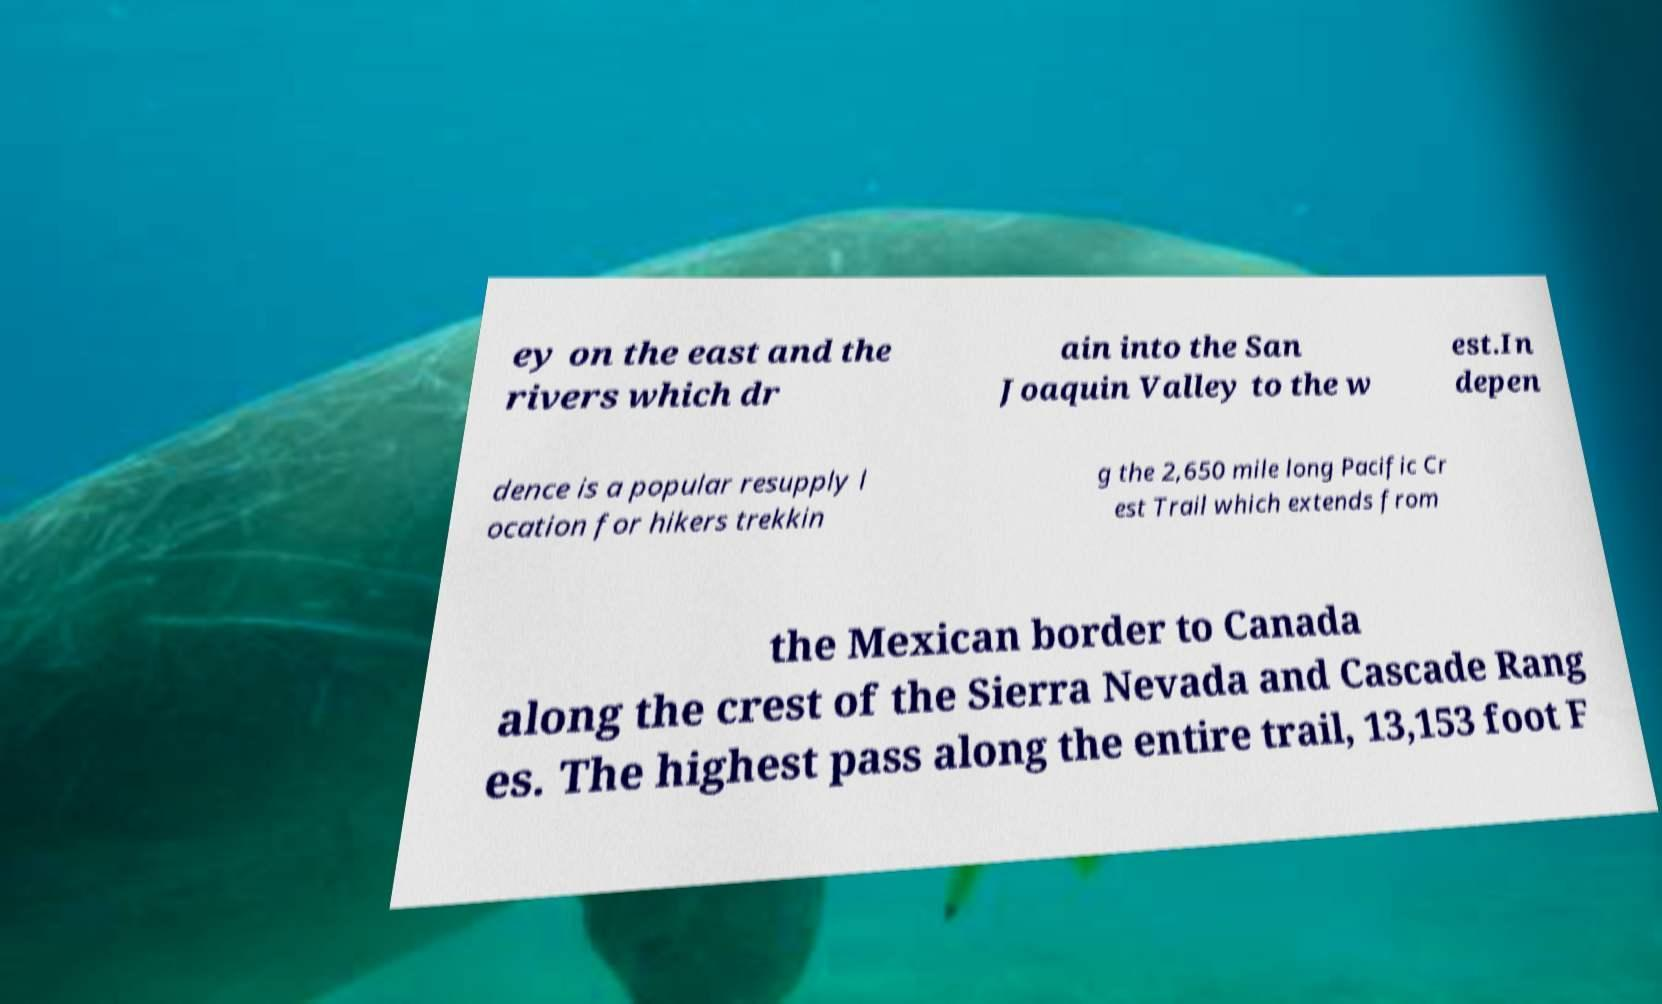Please identify and transcribe the text found in this image. ey on the east and the rivers which dr ain into the San Joaquin Valley to the w est.In depen dence is a popular resupply l ocation for hikers trekkin g the 2,650 mile long Pacific Cr est Trail which extends from the Mexican border to Canada along the crest of the Sierra Nevada and Cascade Rang es. The highest pass along the entire trail, 13,153 foot F 